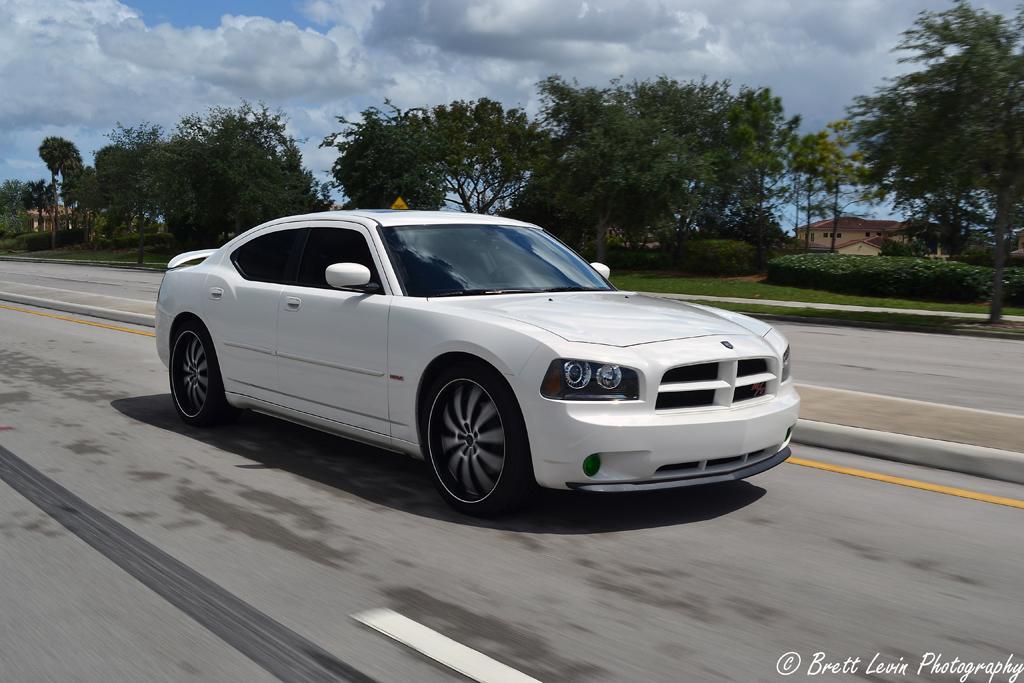Describe this image in one or two sentences. In this image we can see a car which is white in color moving on road and in the background of the image there are some trees, house and cloudy sky. 